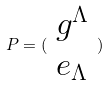Convert formula to latex. <formula><loc_0><loc_0><loc_500><loc_500>P = ( \begin{array} { c } g ^ { \Lambda } \\ e _ { \Lambda } \end{array} )</formula> 